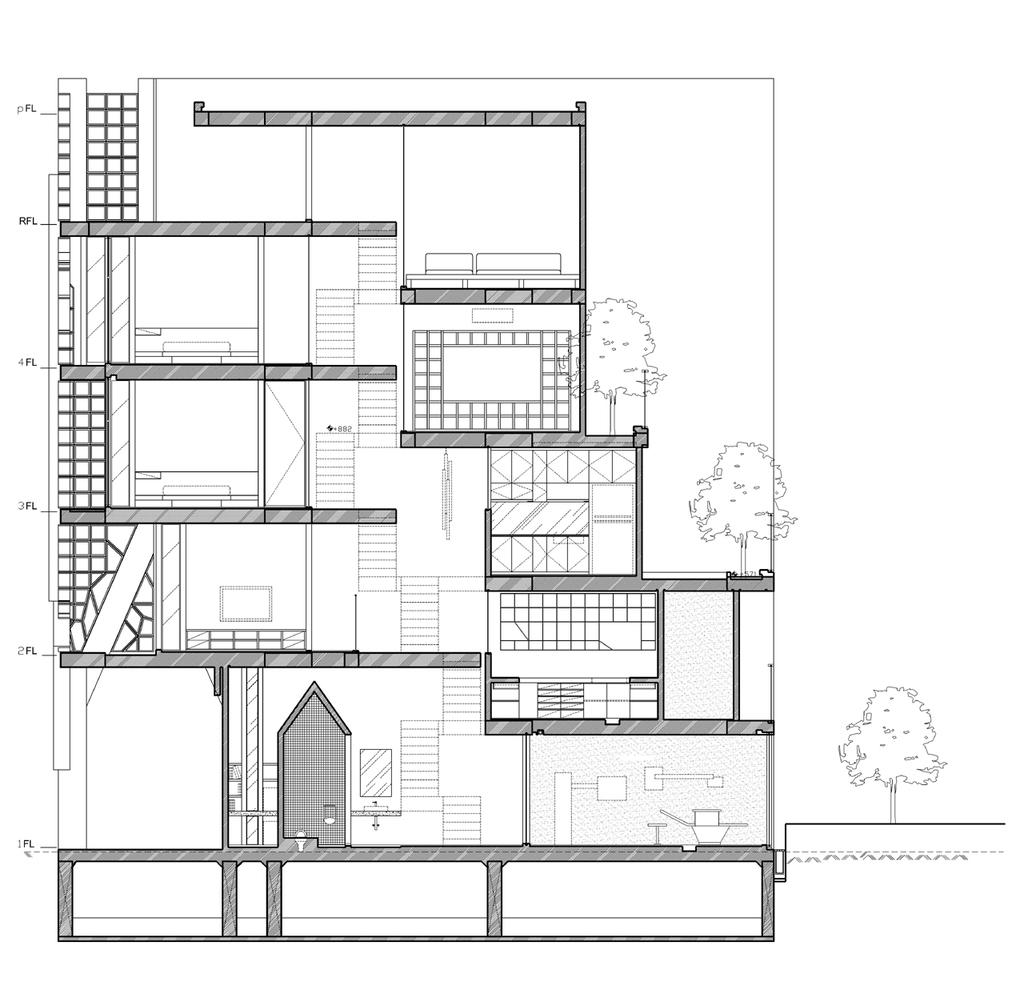What type of document is shown in the image? There is a blueprint of a building in the image. What can be seen in the background of the image? There are trees in the image. How many fish are swimming in the blueprint of the building? There are no fish present in the image, as it features a blueprint of a building and trees. 